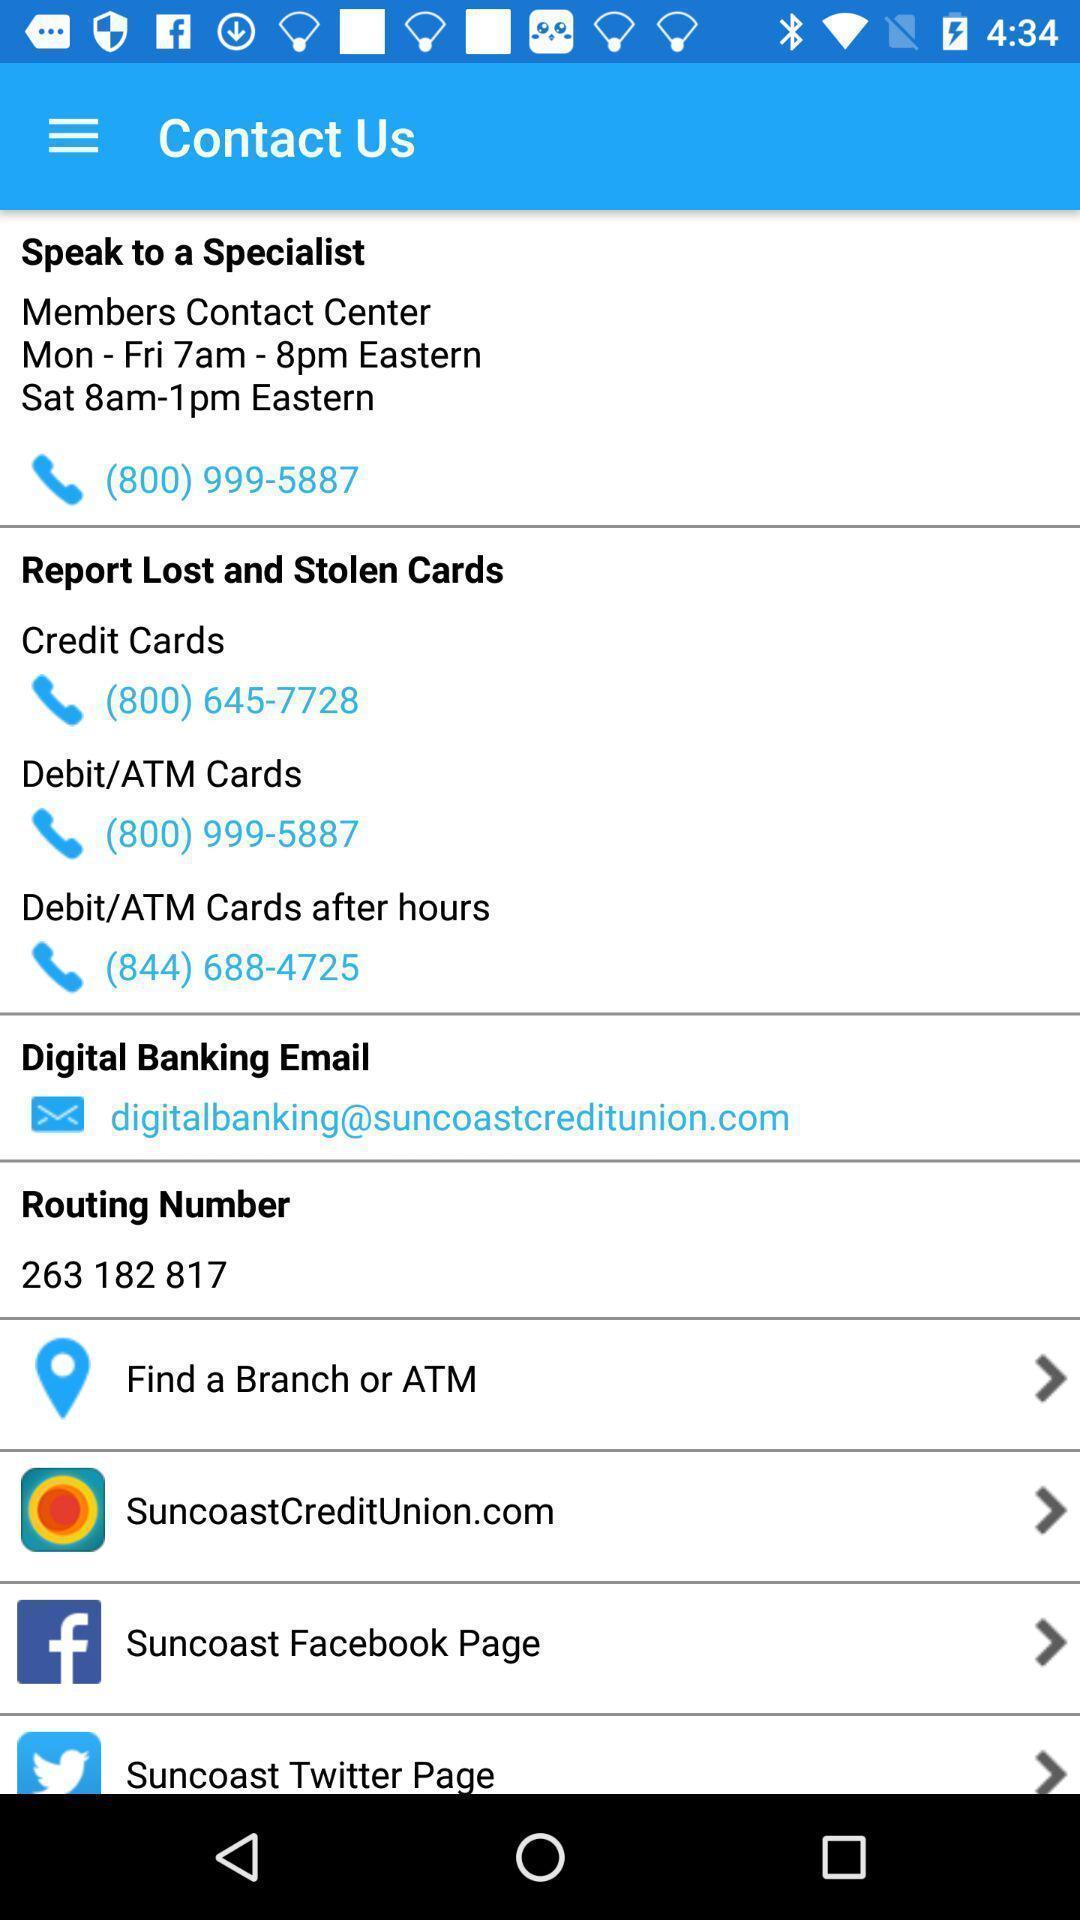Provide a detailed account of this screenshot. Screen displaying multiple options and contact information. 